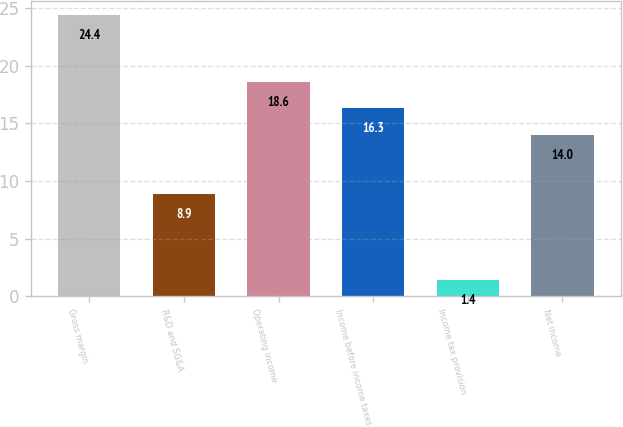Convert chart. <chart><loc_0><loc_0><loc_500><loc_500><bar_chart><fcel>Gross margin<fcel>R&D and SG&A<fcel>Operating income<fcel>Income before income taxes<fcel>Income tax provision<fcel>Net income<nl><fcel>24.4<fcel>8.9<fcel>18.6<fcel>16.3<fcel>1.4<fcel>14<nl></chart> 